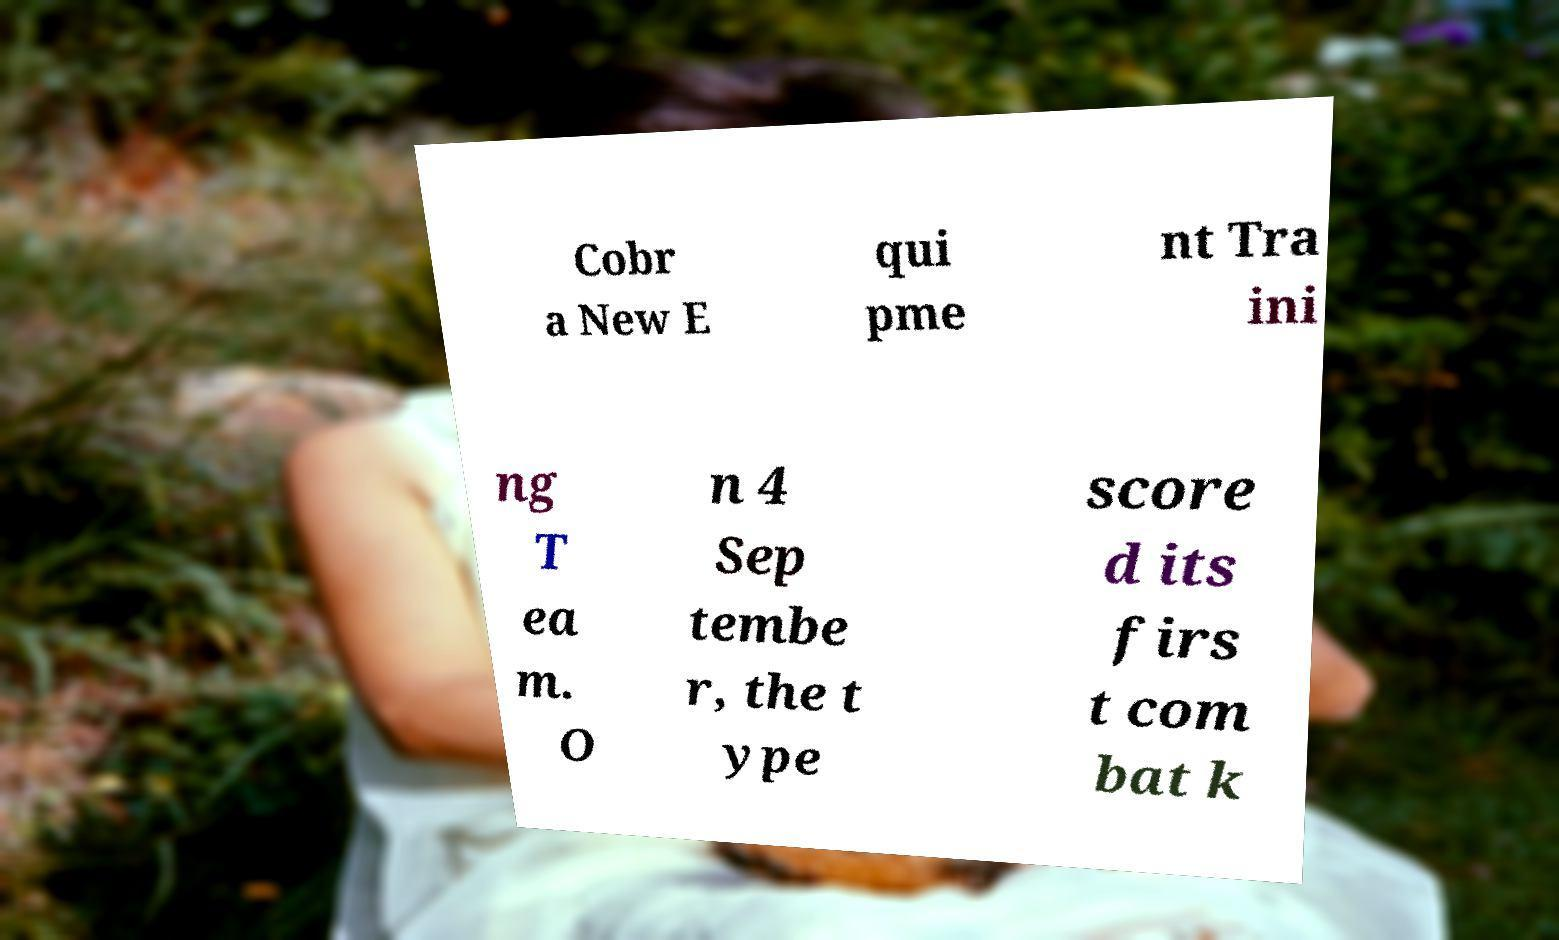Can you accurately transcribe the text from the provided image for me? Cobr a New E qui pme nt Tra ini ng T ea m. O n 4 Sep tembe r, the t ype score d its firs t com bat k 